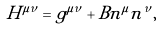<formula> <loc_0><loc_0><loc_500><loc_500>H ^ { \mu \nu } = g ^ { \mu \nu } + B n ^ { \mu } n ^ { \nu } ,</formula> 